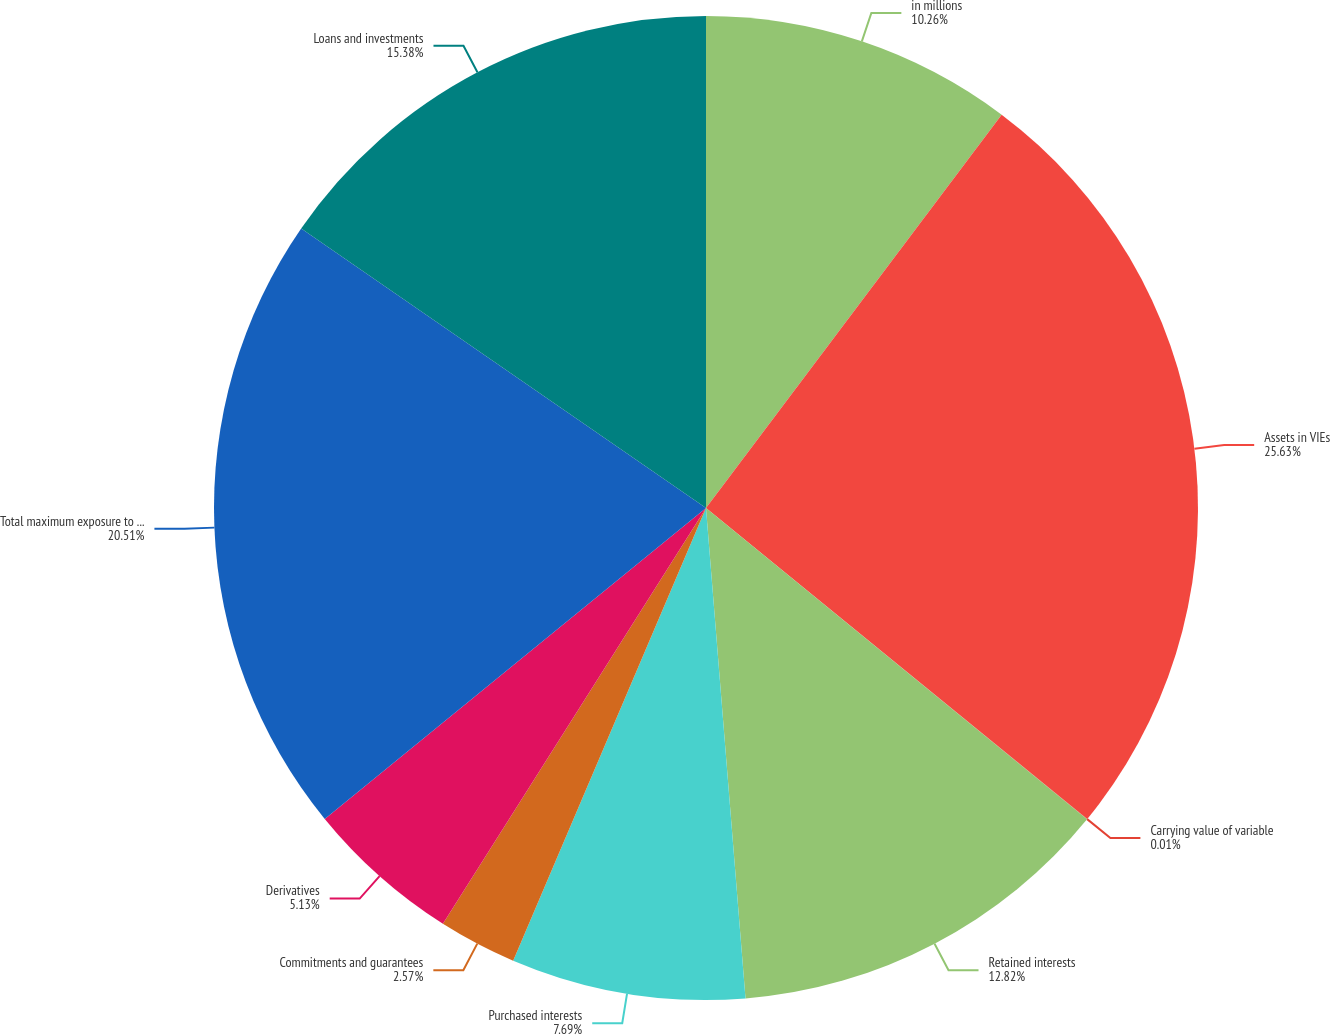Convert chart to OTSL. <chart><loc_0><loc_0><loc_500><loc_500><pie_chart><fcel>in millions<fcel>Assets in VIEs<fcel>Carrying value of variable<fcel>Retained interests<fcel>Purchased interests<fcel>Commitments and guarantees<fcel>Derivatives<fcel>Total maximum exposure to loss<fcel>Loans and investments<nl><fcel>10.26%<fcel>25.63%<fcel>0.01%<fcel>12.82%<fcel>7.69%<fcel>2.57%<fcel>5.13%<fcel>20.51%<fcel>15.38%<nl></chart> 